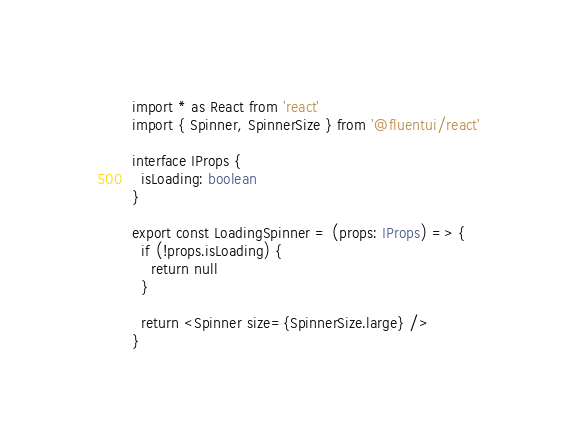Convert code to text. <code><loc_0><loc_0><loc_500><loc_500><_TypeScript_>import * as React from 'react'
import { Spinner, SpinnerSize } from '@fluentui/react'

interface IProps {
  isLoading: boolean
}

export const LoadingSpinner = (props: IProps) => {
  if (!props.isLoading) {
    return null
  }

  return <Spinner size={SpinnerSize.large} />
}</code> 